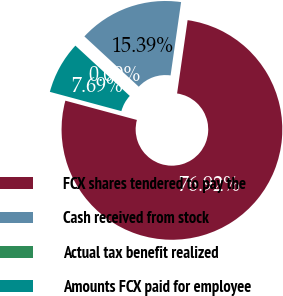Convert chart. <chart><loc_0><loc_0><loc_500><loc_500><pie_chart><fcel>FCX shares tendered to pay the<fcel>Cash received from stock<fcel>Actual tax benefit realized<fcel>Amounts FCX paid for employee<nl><fcel>76.92%<fcel>15.39%<fcel>0.0%<fcel>7.69%<nl></chart> 